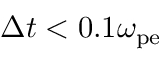Convert formula to latex. <formula><loc_0><loc_0><loc_500><loc_500>\Delta t < 0 . 1 \omega _ { p e }</formula> 